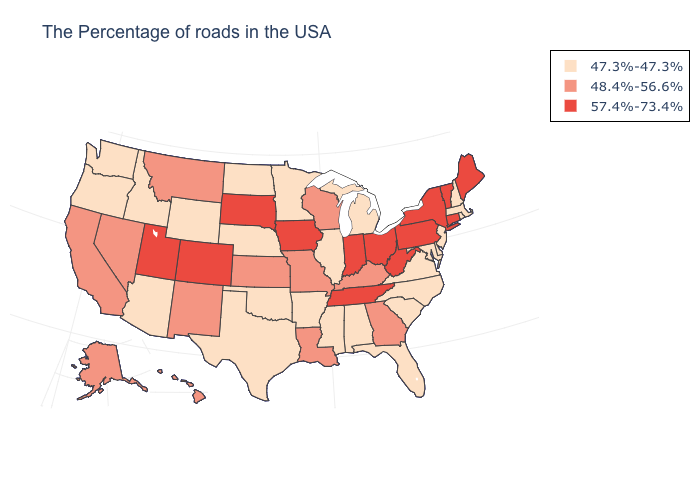Name the states that have a value in the range 57.4%-73.4%?
Short answer required. Maine, Vermont, Connecticut, New York, Pennsylvania, West Virginia, Ohio, Indiana, Tennessee, Iowa, South Dakota, Colorado, Utah. What is the lowest value in the MidWest?
Answer briefly. 47.3%-47.3%. What is the value of Idaho?
Short answer required. 47.3%-47.3%. Name the states that have a value in the range 48.4%-56.6%?
Answer briefly. Georgia, Kentucky, Wisconsin, Louisiana, Missouri, Kansas, New Mexico, Montana, Nevada, California, Alaska, Hawaii. Among the states that border North Dakota , which have the highest value?
Quick response, please. South Dakota. Does Montana have the lowest value in the USA?
Give a very brief answer. No. How many symbols are there in the legend?
Write a very short answer. 3. Among the states that border Connecticut , does New York have the highest value?
Write a very short answer. Yes. What is the lowest value in states that border Maryland?
Keep it brief. 47.3%-47.3%. Name the states that have a value in the range 57.4%-73.4%?
Be succinct. Maine, Vermont, Connecticut, New York, Pennsylvania, West Virginia, Ohio, Indiana, Tennessee, Iowa, South Dakota, Colorado, Utah. What is the value of Kansas?
Keep it brief. 48.4%-56.6%. What is the value of Mississippi?
Keep it brief. 47.3%-47.3%. Does the first symbol in the legend represent the smallest category?
Quick response, please. Yes. How many symbols are there in the legend?
Give a very brief answer. 3. Among the states that border Tennessee , does Virginia have the highest value?
Give a very brief answer. No. 